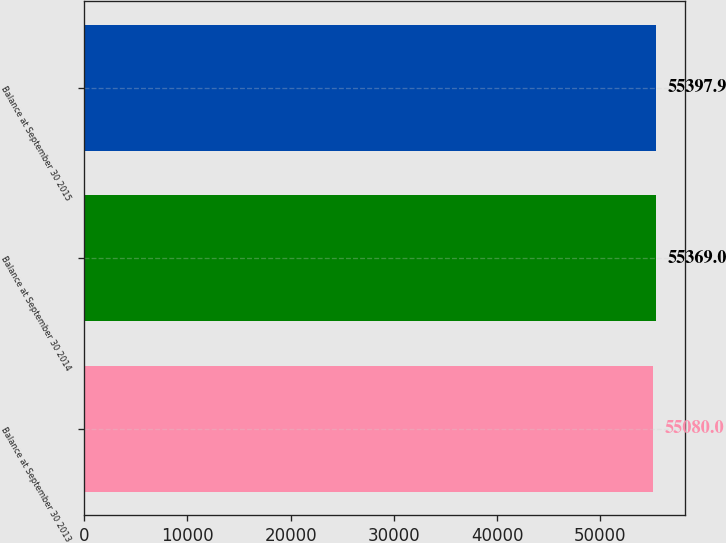Convert chart. <chart><loc_0><loc_0><loc_500><loc_500><bar_chart><fcel>Balance at September 30 2013<fcel>Balance at September 30 2014<fcel>Balance at September 30 2015<nl><fcel>55080<fcel>55369<fcel>55397.9<nl></chart> 